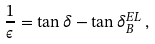Convert formula to latex. <formula><loc_0><loc_0><loc_500><loc_500>\frac { 1 } { \epsilon } = \tan \delta - \tan \delta _ { B } ^ { E L } \, ,</formula> 